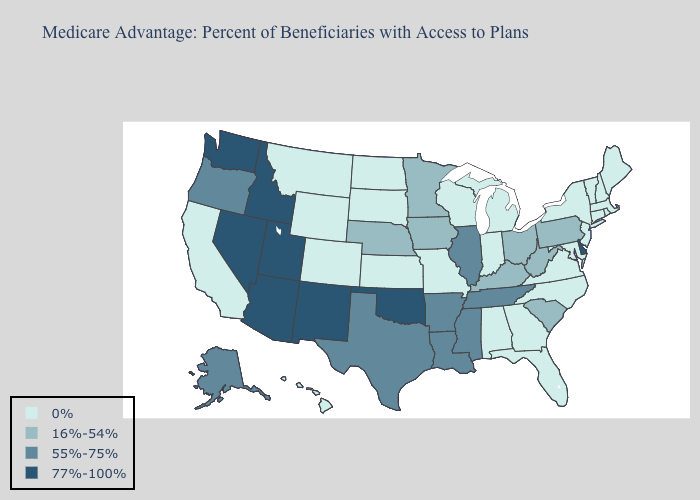Does Pennsylvania have the lowest value in the Northeast?
Be succinct. No. Name the states that have a value in the range 55%-75%?
Give a very brief answer. Alaska, Arkansas, Illinois, Louisiana, Mississippi, Oregon, Tennessee, Texas. What is the value of Iowa?
Be succinct. 16%-54%. What is the value of Pennsylvania?
Keep it brief. 16%-54%. Does Nevada have a lower value than Massachusetts?
Quick response, please. No. Name the states that have a value in the range 0%?
Answer briefly. Alabama, California, Colorado, Connecticut, Florida, Georgia, Hawaii, Indiana, Kansas, Massachusetts, Maryland, Maine, Michigan, Missouri, Montana, North Carolina, North Dakota, New Hampshire, New Jersey, New York, Rhode Island, South Dakota, Virginia, Vermont, Wisconsin, Wyoming. What is the value of Texas?
Give a very brief answer. 55%-75%. Does Idaho have the highest value in the West?
Answer briefly. Yes. What is the value of New York?
Keep it brief. 0%. Name the states that have a value in the range 0%?
Be succinct. Alabama, California, Colorado, Connecticut, Florida, Georgia, Hawaii, Indiana, Kansas, Massachusetts, Maryland, Maine, Michigan, Missouri, Montana, North Carolina, North Dakota, New Hampshire, New Jersey, New York, Rhode Island, South Dakota, Virginia, Vermont, Wisconsin, Wyoming. What is the value of Montana?
Quick response, please. 0%. What is the value of Nevada?
Answer briefly. 77%-100%. Which states hav the highest value in the West?
Answer briefly. Arizona, Idaho, New Mexico, Nevada, Utah, Washington. What is the highest value in the South ?
Give a very brief answer. 77%-100%. Does Idaho have the highest value in the USA?
Concise answer only. Yes. 